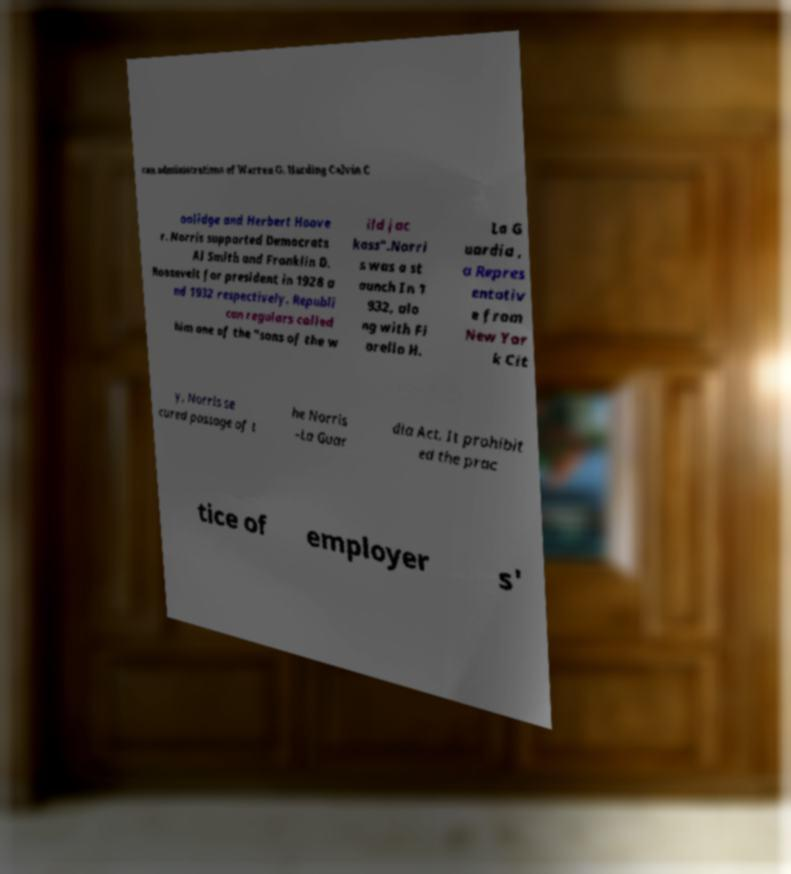Please identify and transcribe the text found in this image. can administrations of Warren G. Harding Calvin C oolidge and Herbert Hoove r. Norris supported Democrats Al Smith and Franklin D. Roosevelt for president in 1928 a nd 1932 respectively. Republi can regulars called him one of the "sons of the w ild jac kass".Norri s was a st aunch In 1 932, alo ng with Fi orello H. La G uardia , a Repres entativ e from New Yor k Cit y, Norris se cured passage of t he Norris –La Guar dia Act. It prohibit ed the prac tice of employer s' 